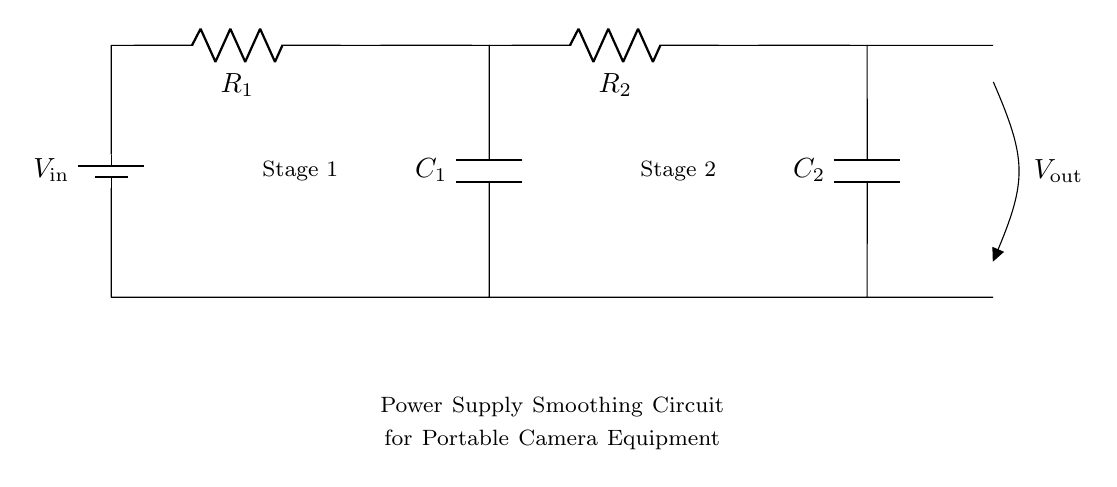What is the input voltage of this circuit? The input voltage is indicated by the label V_in next to the battery symbol, which is the source for the circuit.
Answer: V_in How many resistors are present in the circuit? The circuit diagram shows two resistor components labeled R_1 and R_2, totaling two resistors in the configuration.
Answer: 2 What is the purpose of the capacitors in this circuit? The capacitors, C_1 and C_2, serve to smooth out voltage fluctuations in the power supply, stabilizing the output voltage for consistent performance of the camera equipment.
Answer: Smooth voltage What is the output voltage indicated in the circuit? The output voltage is represented by V_out, which is connected at the end of the second stage where the capacitors and resistors are arranged.
Answer: V_out Which stage connects to the first capacitor? The first stage is connected to C_1, which is part of the first smoothing operation where R_1 and C_1 are used together.
Answer: Stage 1 What is the combined effect of the resistors and capacitors in this circuit? Resistors R_1 and R_2 work in conjunction with capacitors C_1 and C_2 to form a low-pass filter that reduces high-frequency noise in the output voltage, providing a cleaner power supply.
Answer: Reduces noise What happens to the voltage output as more capacitance is added? Increasing the capacitance value will generally result in a lower ripple voltage at the output, enhancing the smoothing effect and stabilizing the supply voltage for the equipment.
Answer: Lower ripple 